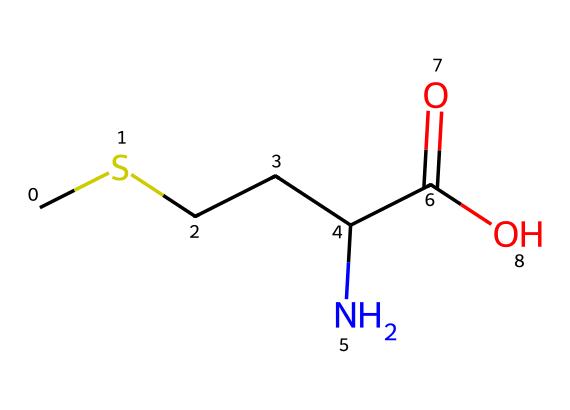What is the total number of carbon atoms in this structure? By inspecting the SMILES representation, the "C" denotes carbon atoms. Counting the occurrences of "C", there are a total of 4 carbon atoms in the given structure.
Answer: 4 How many nitrogen atoms are present in this chemical? The "N" in the SMILES indicates nitrogen. There is a single "N" present, which shows that there is 1 nitrogen atom in the structure.
Answer: 1 What type of functional group is represented by "C(=O)O" in this compound? "C(=O)O" indicates a carboxylic acid functional group, as it has a carbon atom double-bonded to an oxygen and single-bonded to a hydroxyl group.
Answer: carboxylic acid Which element in this compound contributes to its classification as an organosulfur compound? The sulfur atom is the key component that defines this compound as organosulfur; however, the SMILES provided does not explicitly indicate sulfur, but through related amino acids, it is known to be present in protein sources.
Answer: sulfur What is the significance of amino acids in budget-friendly protein sources? Amino acids are essential building blocks of proteins, which are critical for health; they can be found in inexpensive food options like legumes or certain grains, making them significant in a budget context.
Answer: essential 